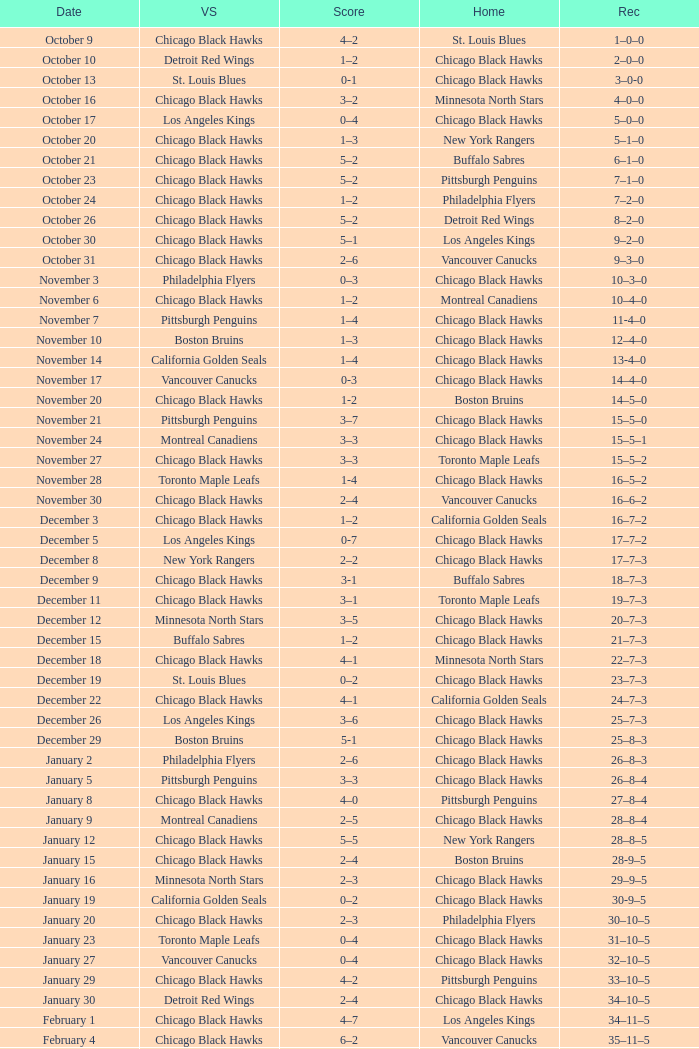What is the Record of the February 26 date? 39–16–7. 